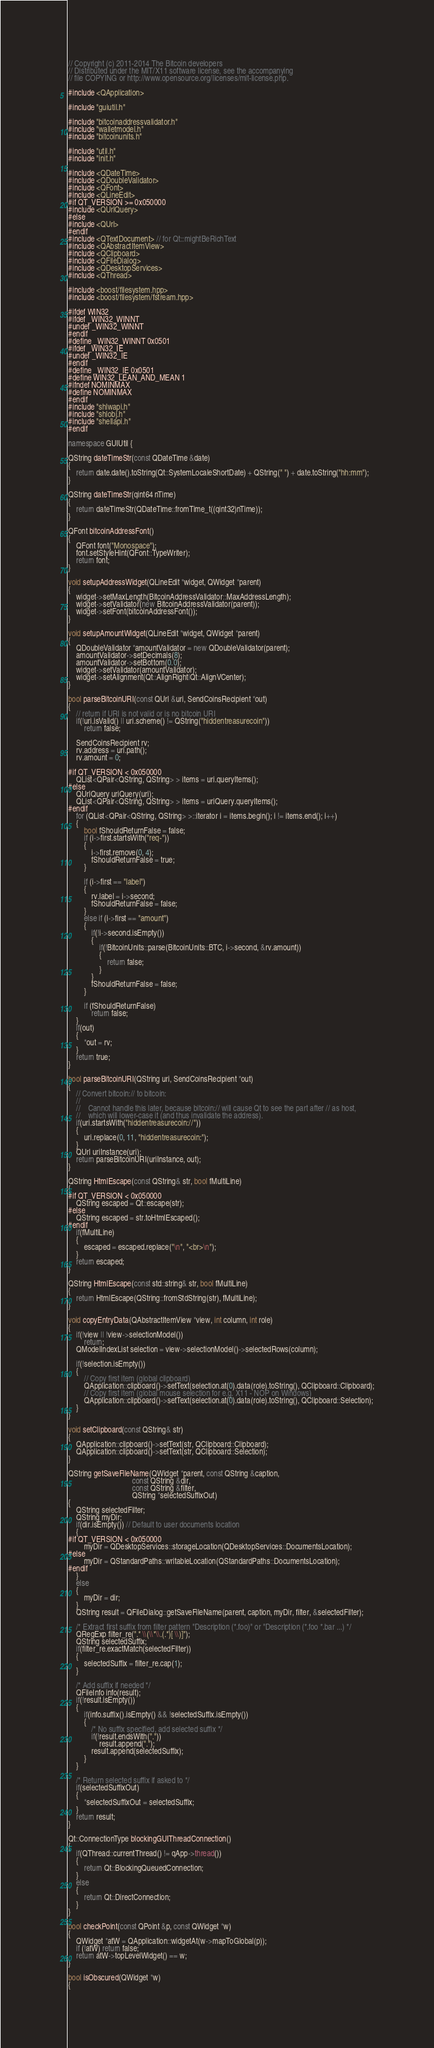<code> <loc_0><loc_0><loc_500><loc_500><_C++_>// Copyright (c) 2011-2014 The Bitcoin developers
// Distributed under the MIT/X11 software license, see the accompanying
// file COPYING or http://www.opensource.org/licenses/mit-license.php.

#include <QApplication>

#include "guiutil.h"

#include "bitcoinaddressvalidator.h"
#include "walletmodel.h"
#include "bitcoinunits.h"

#include "util.h"
#include "init.h"

#include <QDateTime>
#include <QDoubleValidator>
#include <QFont>
#include <QLineEdit>
#if QT_VERSION >= 0x050000
#include <QUrlQuery>
#else
#include <QUrl>
#endif
#include <QTextDocument> // for Qt::mightBeRichText
#include <QAbstractItemView>
#include <QClipboard>
#include <QFileDialog>
#include <QDesktopServices>
#include <QThread>

#include <boost/filesystem.hpp>
#include <boost/filesystem/fstream.hpp>

#ifdef WIN32
#ifdef _WIN32_WINNT
#undef _WIN32_WINNT
#endif
#define _WIN32_WINNT 0x0501
#ifdef _WIN32_IE
#undef _WIN32_IE
#endif
#define _WIN32_IE 0x0501
#define WIN32_LEAN_AND_MEAN 1
#ifndef NOMINMAX
#define NOMINMAX
#endif
#include "shlwapi.h"
#include "shlobj.h"
#include "shellapi.h"
#endif

namespace GUIUtil {

QString dateTimeStr(const QDateTime &date)
{
    return date.date().toString(Qt::SystemLocaleShortDate) + QString(" ") + date.toString("hh:mm");
}

QString dateTimeStr(qint64 nTime)
{
    return dateTimeStr(QDateTime::fromTime_t((qint32)nTime));
}

QFont bitcoinAddressFont()
{
    QFont font("Monospace");
    font.setStyleHint(QFont::TypeWriter);
    return font;
}

void setupAddressWidget(QLineEdit *widget, QWidget *parent)
{
    widget->setMaxLength(BitcoinAddressValidator::MaxAddressLength);
    widget->setValidator(new BitcoinAddressValidator(parent));
    widget->setFont(bitcoinAddressFont());
}

void setupAmountWidget(QLineEdit *widget, QWidget *parent)
{
    QDoubleValidator *amountValidator = new QDoubleValidator(parent);
    amountValidator->setDecimals(8);
    amountValidator->setBottom(0.0);
    widget->setValidator(amountValidator);
    widget->setAlignment(Qt::AlignRight|Qt::AlignVCenter);
}

bool parseBitcoinURI(const QUrl &uri, SendCoinsRecipient *out)
{
    // return if URI is not valid or is no bitcoin URI
    if(!uri.isValid() || uri.scheme() != QString("hiddentreasurecoin"))
        return false;

    SendCoinsRecipient rv;
    rv.address = uri.path();
    rv.amount = 0;

#if QT_VERSION < 0x050000
    QList<QPair<QString, QString> > items = uri.queryItems();
#else
    QUrlQuery uriQuery(uri);
    QList<QPair<QString, QString> > items = uriQuery.queryItems();
#endif
    for (QList<QPair<QString, QString> >::iterator i = items.begin(); i != items.end(); i++)
    {
        bool fShouldReturnFalse = false;
        if (i->first.startsWith("req-"))
        {
            i->first.remove(0, 4);
            fShouldReturnFalse = true;
        }

        if (i->first == "label")
        {
            rv.label = i->second;
            fShouldReturnFalse = false;
        }
        else if (i->first == "amount")
        {
            if(!i->second.isEmpty())
            {
                if(!BitcoinUnits::parse(BitcoinUnits::BTC, i->second, &rv.amount))
                {
                    return false;
                }
            }
            fShouldReturnFalse = false;
        }

        if (fShouldReturnFalse)
            return false;
    }
    if(out)
    {
        *out = rv;
    }
    return true;
}

bool parseBitcoinURI(QString uri, SendCoinsRecipient *out)
{
    // Convert bitcoin:// to bitcoin:
    //
    //    Cannot handle this later, because bitcoin:// will cause Qt to see the part after // as host,
    //    which will lower-case it (and thus invalidate the address).
    if(uri.startsWith("hiddentreasurecoin://"))
    {
        uri.replace(0, 11, "hiddentreasurecoin:");
    }
    QUrl uriInstance(uri);
    return parseBitcoinURI(uriInstance, out);
}

QString HtmlEscape(const QString& str, bool fMultiLine)
{
#if QT_VERSION < 0x050000
    QString escaped = Qt::escape(str);
#else
    QString escaped = str.toHtmlEscaped();
#endif
    if(fMultiLine)
    {
        escaped = escaped.replace("\n", "<br>\n");
    }
    return escaped;
}

QString HtmlEscape(const std::string& str, bool fMultiLine)
{
    return HtmlEscape(QString::fromStdString(str), fMultiLine);
}

void copyEntryData(QAbstractItemView *view, int column, int role)
{
    if(!view || !view->selectionModel())
        return;
    QModelIndexList selection = view->selectionModel()->selectedRows(column);

    if(!selection.isEmpty())
    {
        // Copy first item (global clipboard)
        QApplication::clipboard()->setText(selection.at(0).data(role).toString(), QClipboard::Clipboard);
        // Copy first item (global mouse selection for e.g. X11 - NOP on Windows)
        QApplication::clipboard()->setText(selection.at(0).data(role).toString(), QClipboard::Selection);
    }
}

void setClipboard(const QString& str)
{
    QApplication::clipboard()->setText(str, QClipboard::Clipboard);
    QApplication::clipboard()->setText(str, QClipboard::Selection);
}

QString getSaveFileName(QWidget *parent, const QString &caption,
                                 const QString &dir,
                                 const QString &filter,
                                 QString *selectedSuffixOut)
{
    QString selectedFilter;
    QString myDir;
    if(dir.isEmpty()) // Default to user documents location
    {
#if QT_VERSION < 0x050000
        myDir = QDesktopServices::storageLocation(QDesktopServices::DocumentsLocation);
#else
        myDir = QStandardPaths::writableLocation(QStandardPaths::DocumentsLocation);
#endif
    }
    else
    {
        myDir = dir;
    }
    QString result = QFileDialog::getSaveFileName(parent, caption, myDir, filter, &selectedFilter);

    /* Extract first suffix from filter pattern "Description (*.foo)" or "Description (*.foo *.bar ...) */
    QRegExp filter_re(".* \\(\\*\\.(.*)[ \\)]");
    QString selectedSuffix;
    if(filter_re.exactMatch(selectedFilter))
    {
        selectedSuffix = filter_re.cap(1);
    }

    /* Add suffix if needed */
    QFileInfo info(result);
    if(!result.isEmpty())
    {
        if(info.suffix().isEmpty() && !selectedSuffix.isEmpty())
        {
            /* No suffix specified, add selected suffix */
            if(!result.endsWith("."))
                result.append(".");
            result.append(selectedSuffix);
        }
    }

    /* Return selected suffix if asked to */
    if(selectedSuffixOut)
    {
        *selectedSuffixOut = selectedSuffix;
    }
    return result;
}

Qt::ConnectionType blockingGUIThreadConnection()
{
    if(QThread::currentThread() != qApp->thread())
    {
        return Qt::BlockingQueuedConnection;
    }
    else
    {
        return Qt::DirectConnection;
    }
}

bool checkPoint(const QPoint &p, const QWidget *w)
{
    QWidget *atW = QApplication::widgetAt(w->mapToGlobal(p));
    if (!atW) return false;
    return atW->topLevelWidget() == w;
}

bool isObscured(QWidget *w)
{</code> 